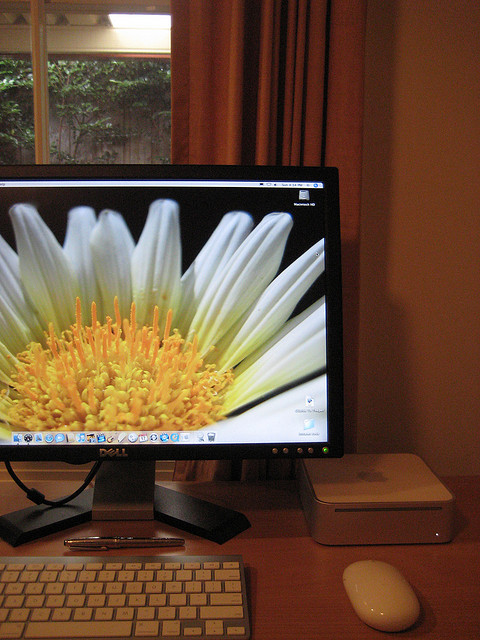<image>What is the object that holds the flowers? It is ambiguous what object holds the flowers. It could be a vase or a computer monitor. What is the object that holds the flowers? I am not sure what is the object that holds the flowers. It can be seen as a computer monitor, screen or monitor. 